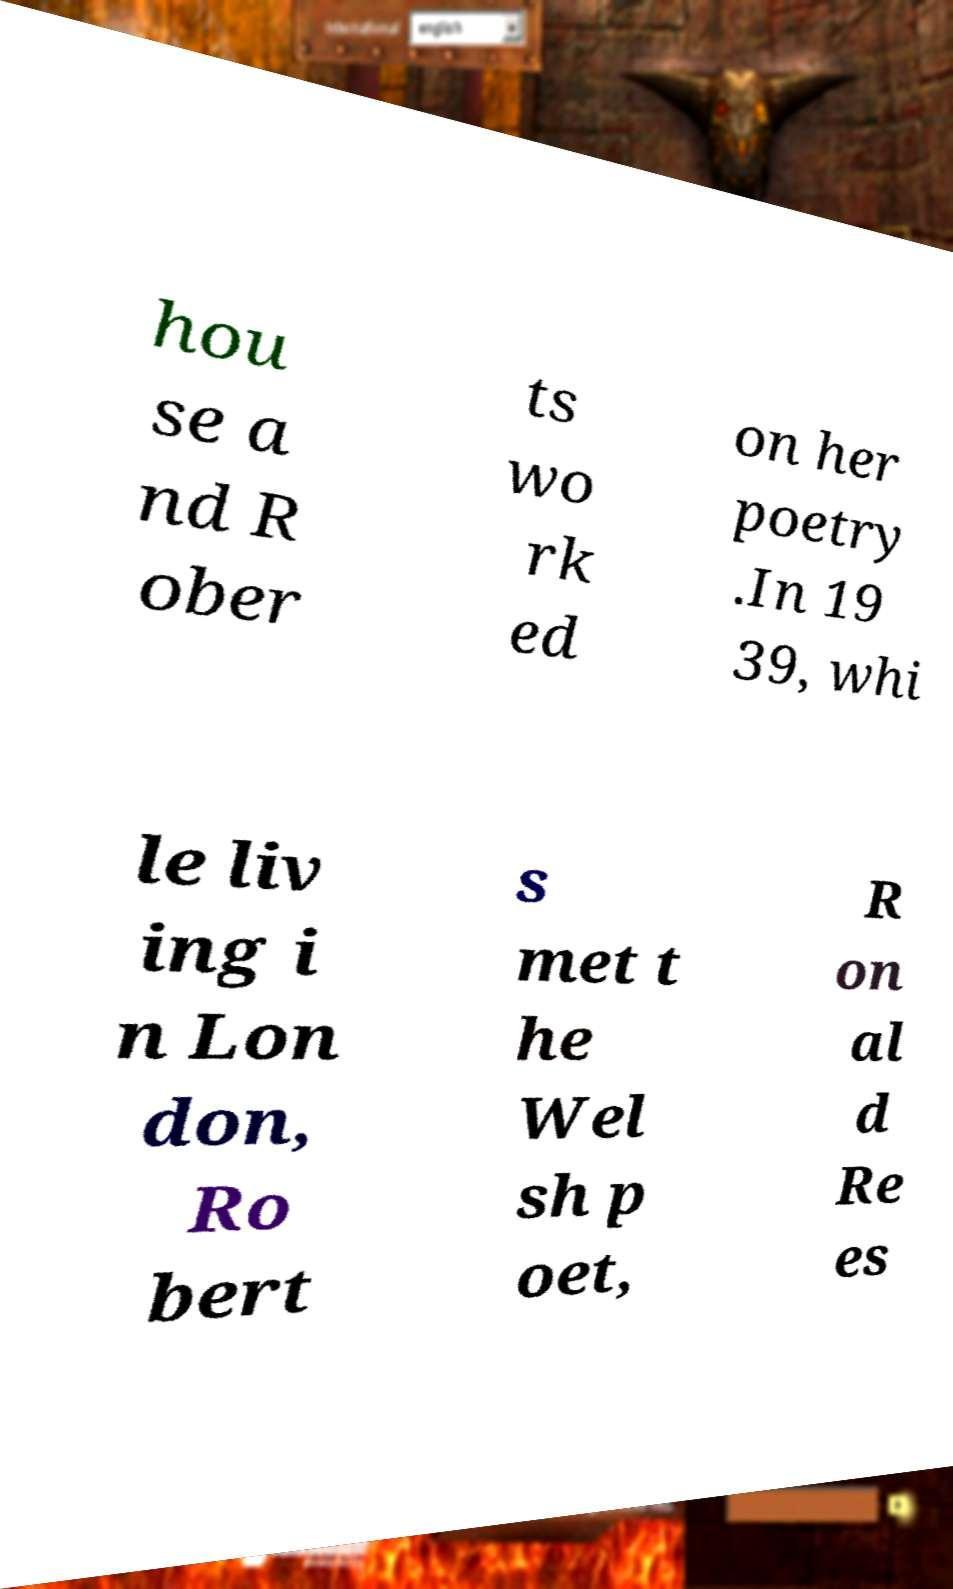What messages or text are displayed in this image? I need them in a readable, typed format. hou se a nd R ober ts wo rk ed on her poetry .In 19 39, whi le liv ing i n Lon don, Ro bert s met t he Wel sh p oet, R on al d Re es 